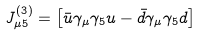Convert formula to latex. <formula><loc_0><loc_0><loc_500><loc_500>J _ { \mu 5 } ^ { ( 3 ) } = \left [ { \bar { u } } \gamma _ { \mu } \gamma _ { 5 } u - { \bar { d } } \gamma _ { \mu } \gamma _ { 5 } d \right ]</formula> 